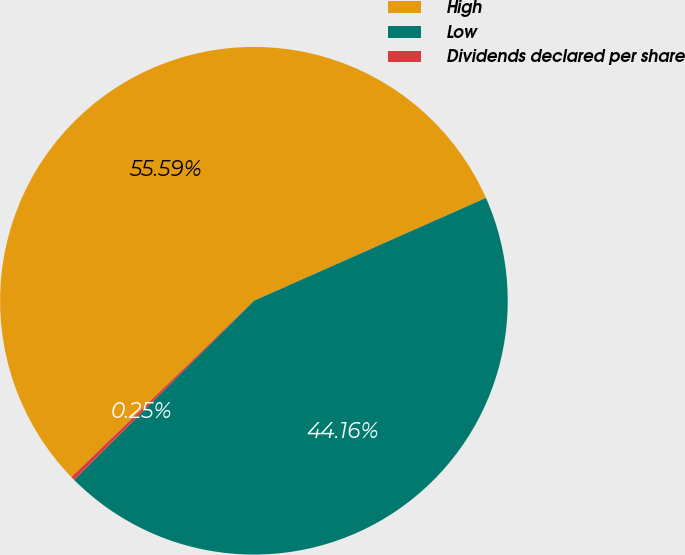Convert chart. <chart><loc_0><loc_0><loc_500><loc_500><pie_chart><fcel>High<fcel>Low<fcel>Dividends declared per share<nl><fcel>55.58%<fcel>44.16%<fcel>0.25%<nl></chart> 